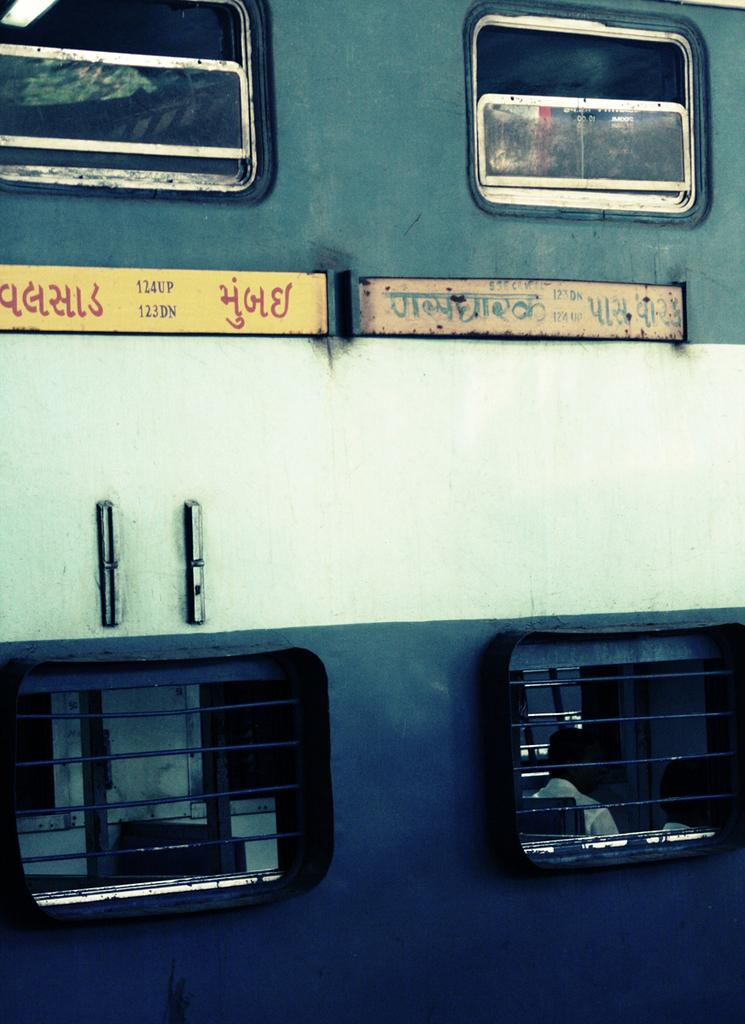What is the main subject of the image? The main subject of the image is a train. What can be seen on the train in the image? There are name boards on the train in the image. What are the people in the image doing? There are persons sitting on seats in the image. What type of street is visible in the image? There is no street visible in the image; it features a train with name boards and people sitting on seats. How many screws can be seen holding the train together in the image? There is no mention of screws in the image; it focuses on the train, name boards, and people sitting on seats. 